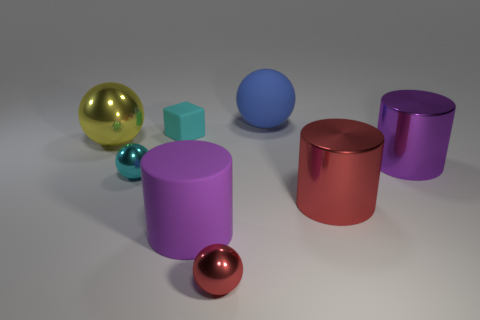Subtract 1 spheres. How many spheres are left? 3 Add 2 cylinders. How many objects exist? 10 Subtract all cubes. How many objects are left? 7 Subtract all tiny rubber cylinders. Subtract all blocks. How many objects are left? 7 Add 5 cyan metal objects. How many cyan metal objects are left? 6 Add 3 small cyan spheres. How many small cyan spheres exist? 4 Subtract 1 red balls. How many objects are left? 7 